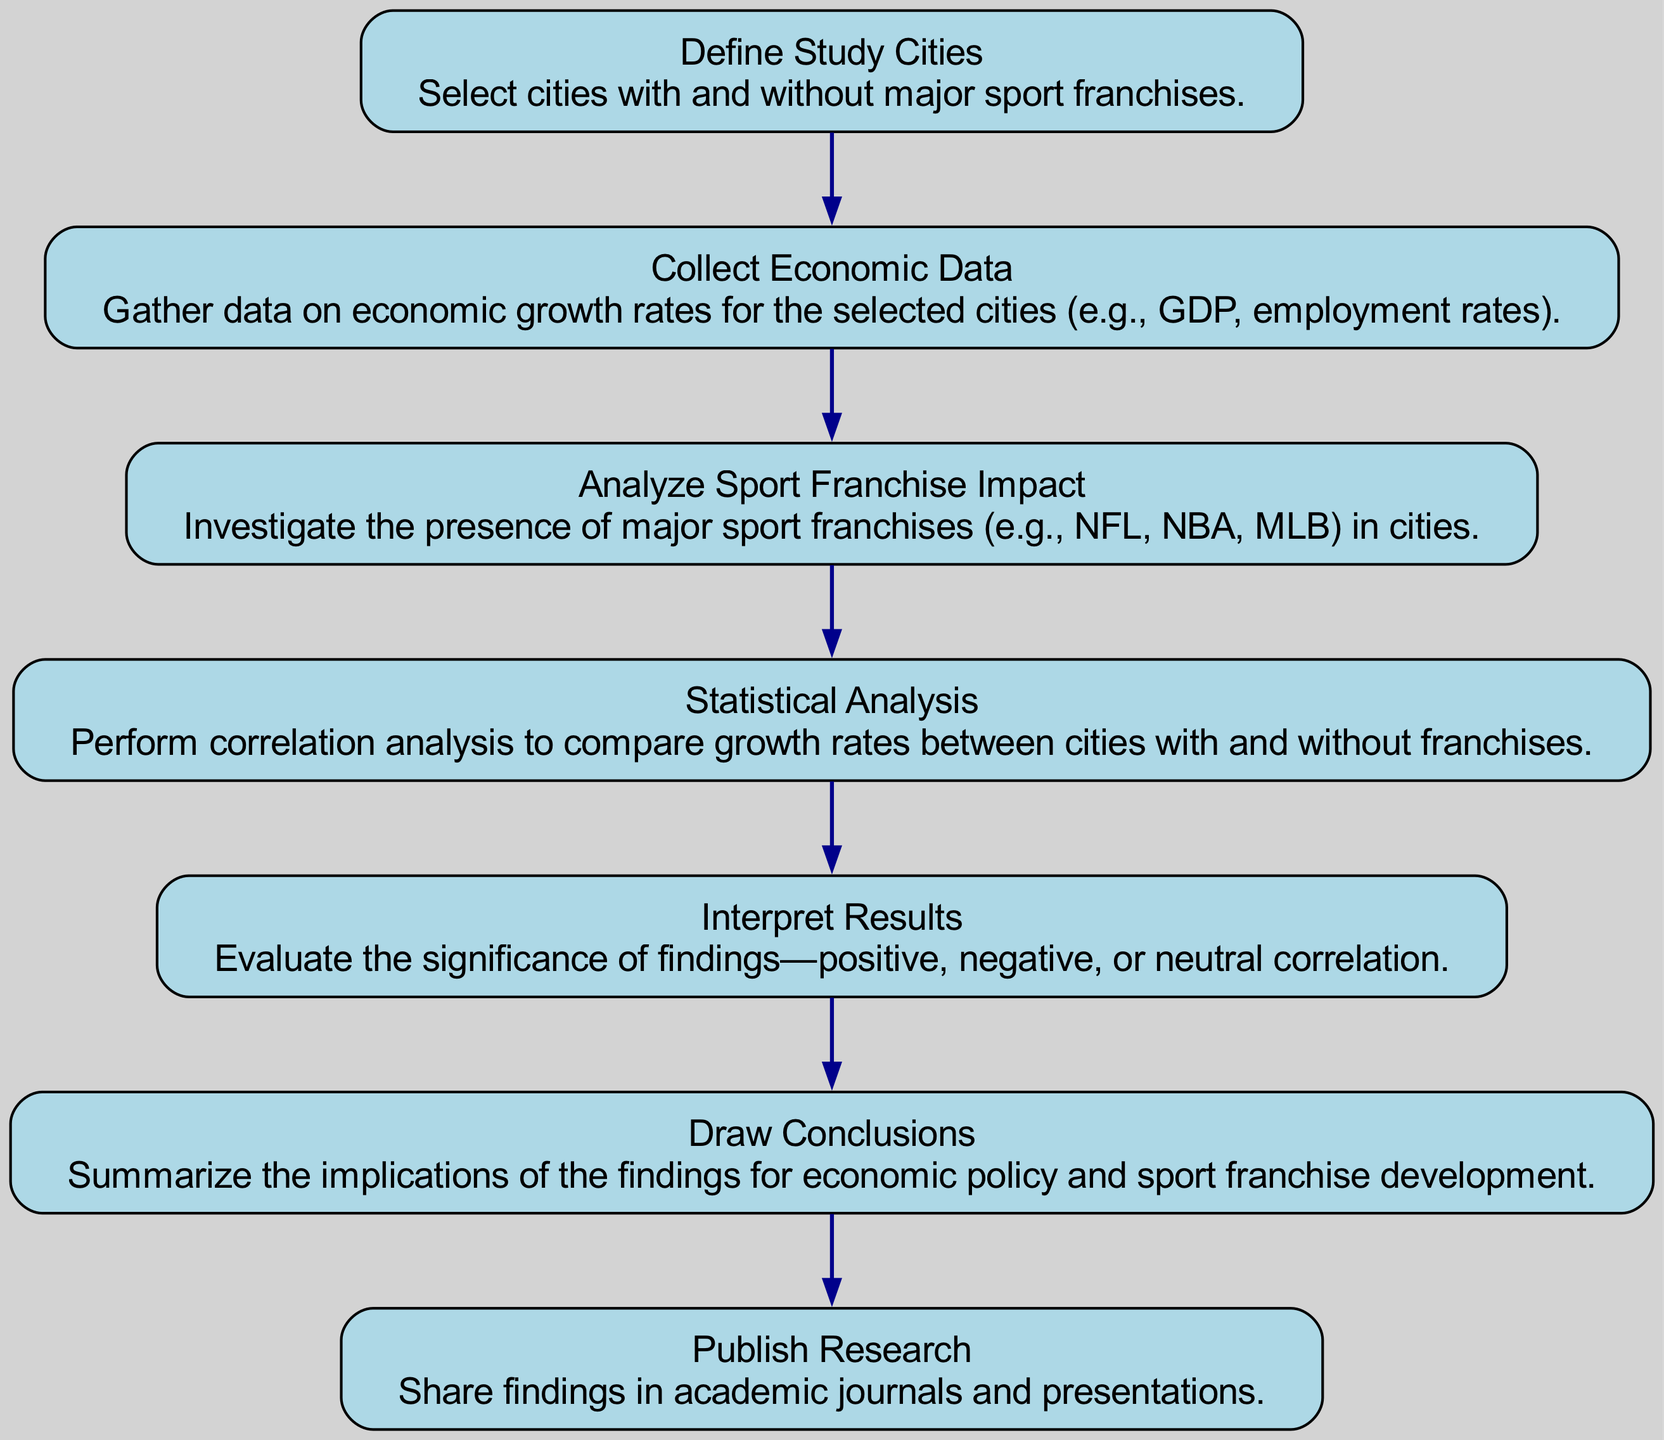What is the first step in the flowchart? The first step is "Define Study Cities," where cities with and without major sport franchises are selected. This is indicated by the node at the top of the flowchart labeled "Define Study Cities."
Answer: Define Study Cities How many nodes are in the diagram? By counting each node (from A to G), the total is seven. This includes all steps from defining the study cities to publishing the research.
Answer: Seven What type of data is collected in step B? Step B specifies the collection of economic data, which includes GDP and employment rates for the selected cities. The node explains that this refers to economic growth rates in various cities.
Answer: Economic data Which step follows the analysis of sport franchise impact? The step that follows "Analyze Sport Franchise Impact" (step C) is "Statistical Analysis" (step D). The flowchart shows a direct arrow from C to D indicating the sequence.
Answer: Statistical Analysis What is the objective of the final step in the flowchart? The final step, "Publish Research," aims to share the findings in academic journals and presentations, as denoted in the description of the last node.
Answer: Share findings Is there a correlation analysis in the flowchart? Yes, a correlation analysis is performed in step D, as indicated by the node labeled "Statistical Analysis," which focuses on comparing growth rates between cities with and without franchises.
Answer: Yes How do the findings of the analysis impact economic policy? The impact is summarized in the "Draw Conclusions" step (F), where the implications of the findings for economic policy and sport franchise development are evaluated, showing a connection to real-world applications.
Answer: Implications for economic policy What is the relationship between "Collect Economic Data" and "Analyze Sport Franchise Impact"? The relationship is sequential; you must first collect economic data before analyzing the sport franchise impact. The flowchart has an arrow leading from "Collect Economic Data" (B) to "Analyze Sport Franchise Impact" (C).
Answer: Sequential relationship What type of research is published in the final step? The final step indicates that findings are published in academic journals and presentations, reflecting original research work based on the comparisons and analyses conducted throughout the flowchart.
Answer: Academic research 